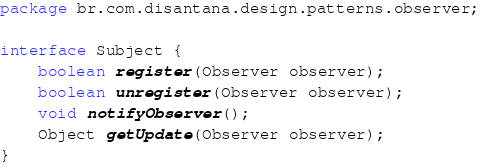<code> <loc_0><loc_0><loc_500><loc_500><_Java_>package br.com.disantana.design.patterns.observer;

interface Subject {
    boolean register(Observer observer);
    boolean unregister(Observer observer);
    void notifyObserver();
    Object getUpdate(Observer observer);
}
</code> 